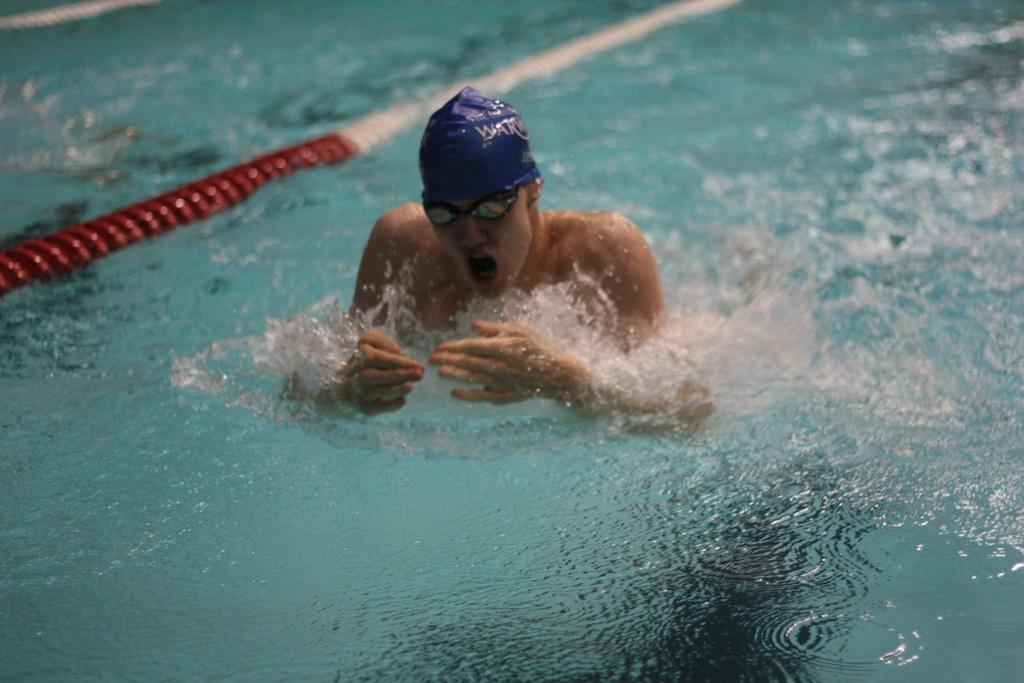What is the man in the image doing? The man is in the swimming pool. Can you describe any other objects or features in the image? There is a red and white color pipe in the image. What type of downtown area can be seen in the image? There is no downtown area present in the image; it features a man in a swimming pool and a red and white color pipe. How many stars are visible in the image? There are no stars visible in the image. 